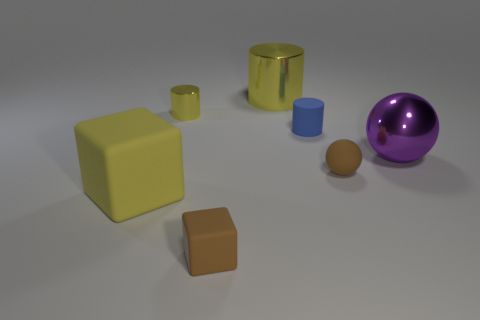Add 1 tiny brown rubber spheres. How many objects exist? 8 Subtract all cylinders. How many objects are left? 4 Subtract all brown shiny spheres. Subtract all large shiny spheres. How many objects are left? 6 Add 7 tiny yellow objects. How many tiny yellow objects are left? 8 Add 3 brown balls. How many brown balls exist? 4 Subtract 0 red cylinders. How many objects are left? 7 